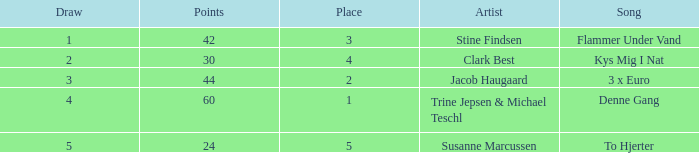What is the Draw that has Points larger than 44 and a Place larger than 1? None. 